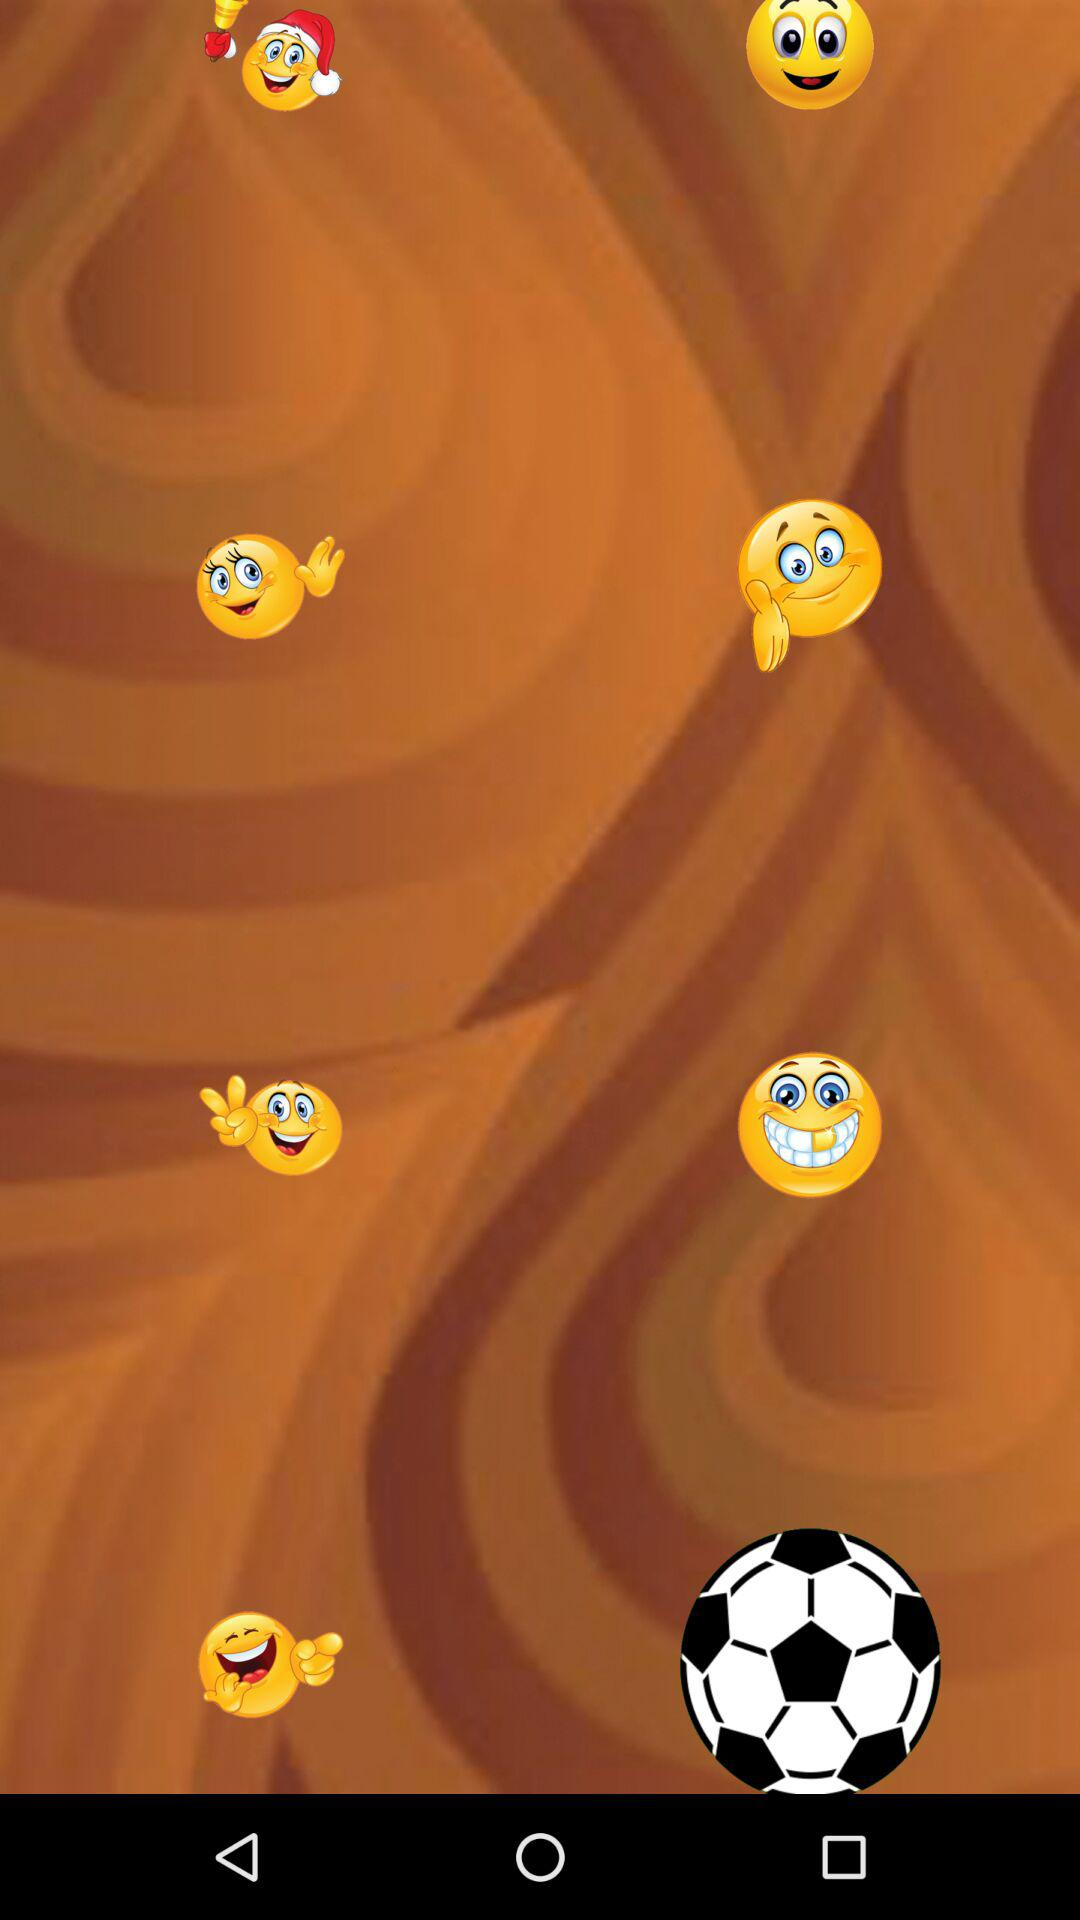How many smiley faces have a hand behind them?
Answer the question using a single word or phrase. 4 